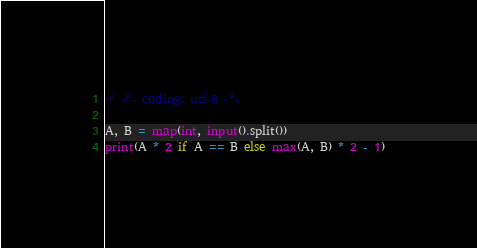Convert code to text. <code><loc_0><loc_0><loc_500><loc_500><_Python_># -*- coding: utf-8 -*-

A, B = map(int, input().split())
print(A * 2 if A == B else max(A, B) * 2 - 1)
</code> 